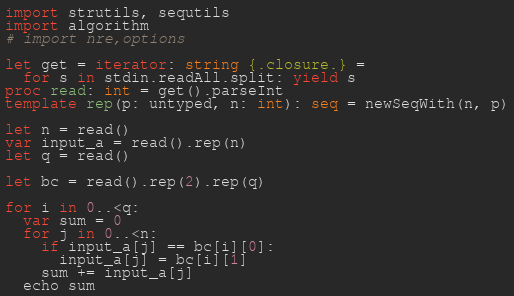<code> <loc_0><loc_0><loc_500><loc_500><_Nim_>import strutils, sequtils
import algorithm
# import nre,options

let get = iterator: string {.closure.} =
  for s in stdin.readAll.split: yield s
proc read: int = get().parseInt
template rep(p: untyped, n: int): seq = newSeqWith(n, p)

let n = read()
var input_a = read().rep(n)
let q = read()

let bc = read().rep(2).rep(q)

for i in 0..<q:
  var sum = 0
  for j in 0..<n:
    if input_a[j] == bc[i][0]:
      input_a[j] = bc[i][1]
    sum += input_a[j]
  echo sum</code> 